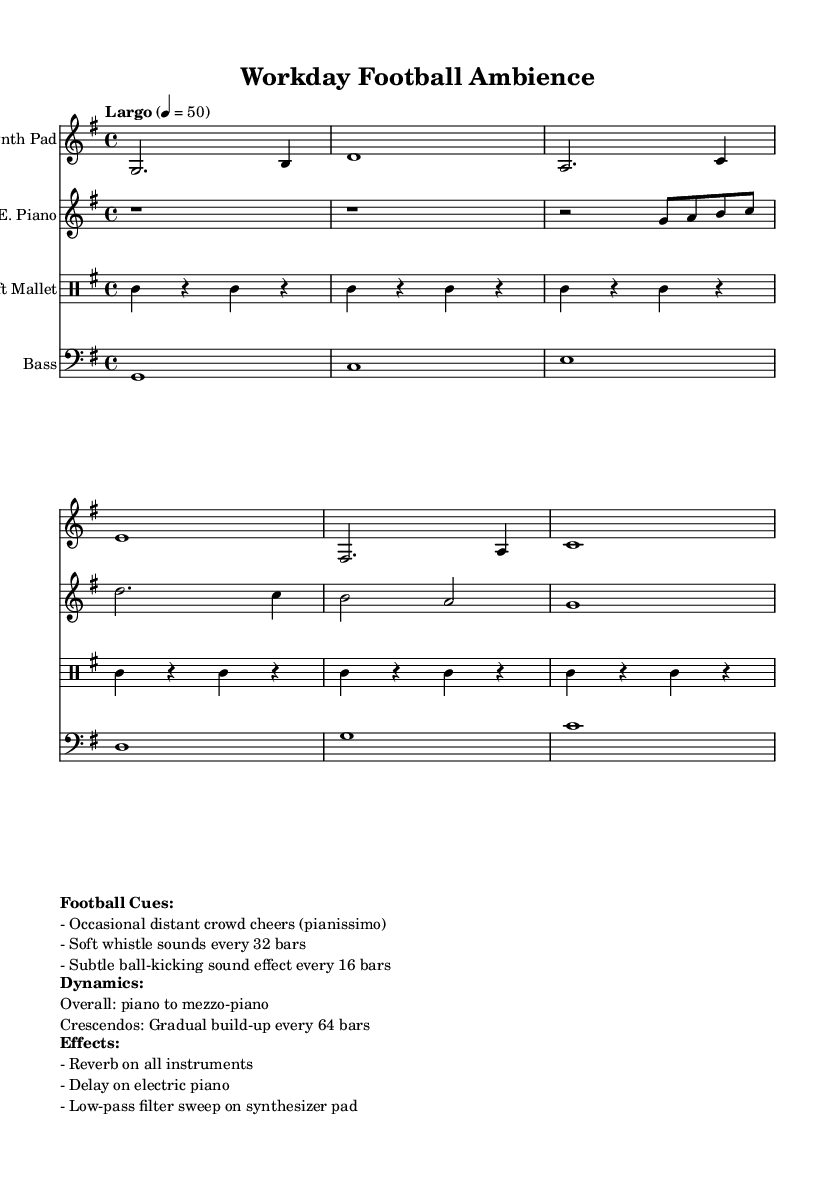What is the key signature of this music? The music is in G major, which has one sharp (F#) indicated by the key signature at the beginning of the staff.
Answer: G major What is the time signature of this piece? The time signature is 4/4, as indicated at the beginning of the score, meaning there are four beats per measure.
Answer: 4/4 What is the tempo marking for this music? The tempo marking is "Largo," which indicates a slow tempo, specifically 50 beats per minute as shown in the score.
Answer: Largo How many bars are there between the subtle ball-kicking sound effects? Based on the score notes, the ball-kicking sound is indicated to happen every 16 bars.
Answer: 16 bars What dynamic levels are indicated for this composition? The overall dynamic level is marked as piano to mezzo-piano, suggesting that the music should be played softly to moderately soft throughout.
Answer: Piano to mezzo-piano Which instrument is associated with the soft mallet sound? The score labels the soft mallet as a separate instrument in the percussion section, indicating the specific sound being produced by this instrument.
Answer: Soft mallet What type of audio effects are applied to the instruments? The score states that all instruments have reverb, the electric piano has delay, and the synthesizer pad undergoes a low-pass filter sweep.
Answer: Reverb, delay, low-pass filter 